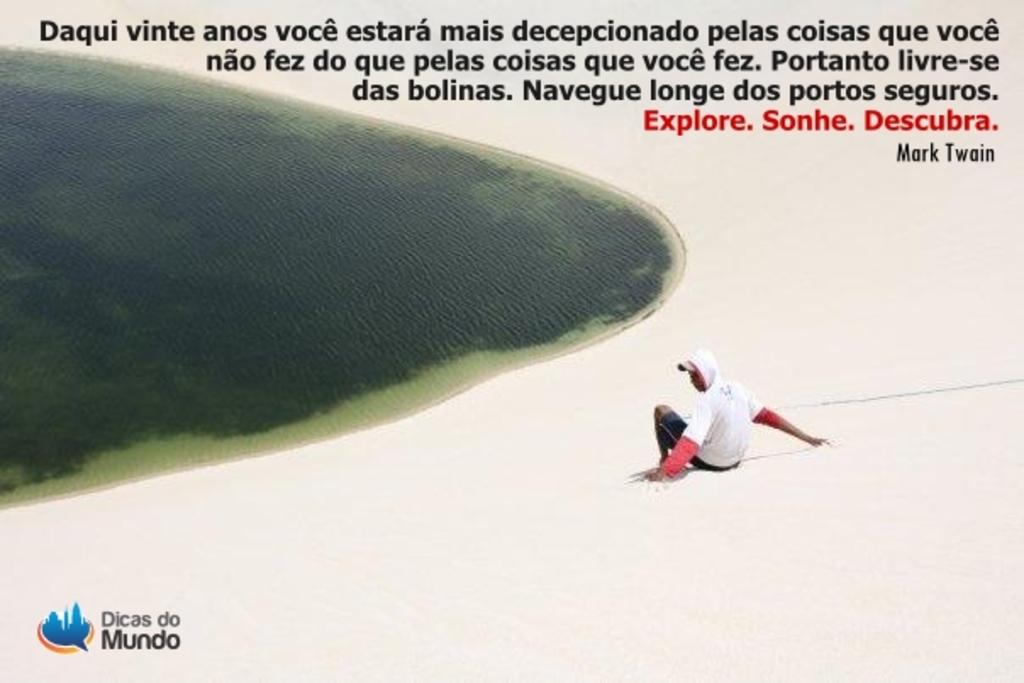<image>
Describe the image concisely. A Mark Twain quote is written in Spanish over a beach scene. 